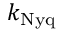Convert formula to latex. <formula><loc_0><loc_0><loc_500><loc_500>k _ { N y q }</formula> 